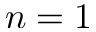Convert formula to latex. <formula><loc_0><loc_0><loc_500><loc_500>n = 1</formula> 